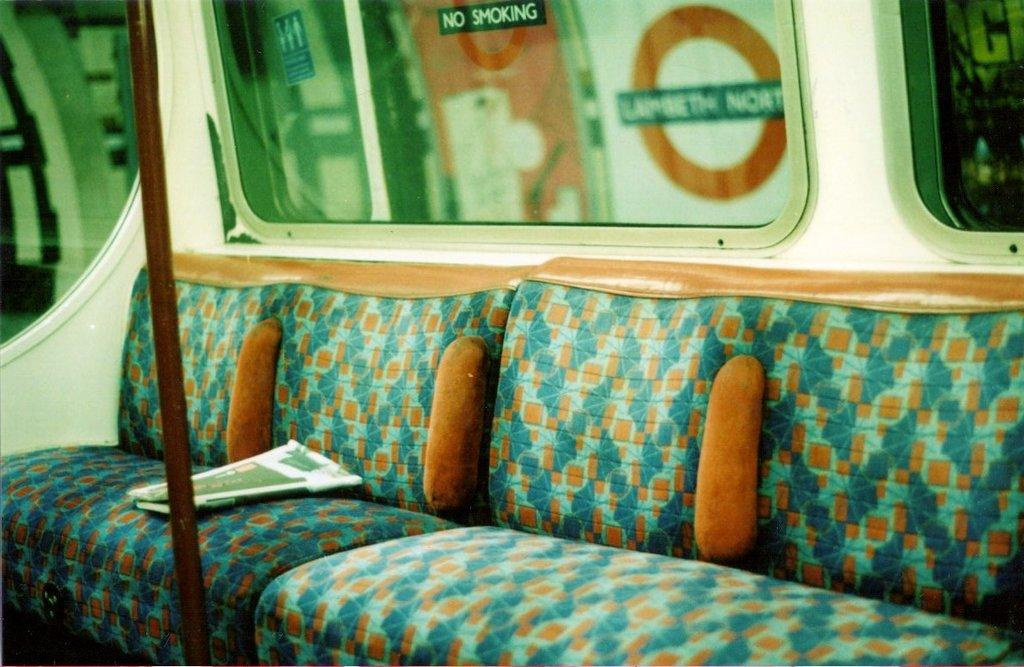What is the main subject of the image? The image shows the inner part of a vehicle. What type of seating is present in the vehicle? There is a couch in the vehicle. What colors can be seen on the couch? The couch has orange and green colors. What can be seen through the windows in the background of the image? There are windows visible in the background of the image, but the specific view is not mentioned in the facts. How many cakes are displayed on the couch in the image? There is no mention of cakes in the image, so it is impossible to determine their presence or quantity. 